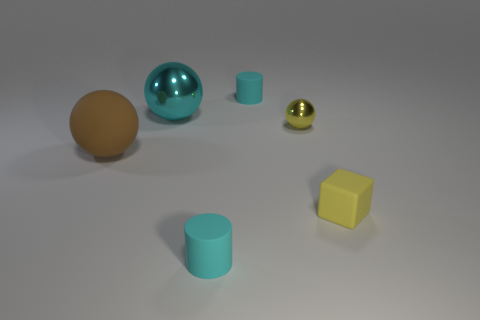Add 3 big brown rubber things. How many objects exist? 9 Subtract all cylinders. How many objects are left? 4 Subtract all purple matte balls. Subtract all large cyan balls. How many objects are left? 5 Add 1 small yellow cubes. How many small yellow cubes are left? 2 Add 5 tiny shiny spheres. How many tiny shiny spheres exist? 6 Subtract 0 red blocks. How many objects are left? 6 